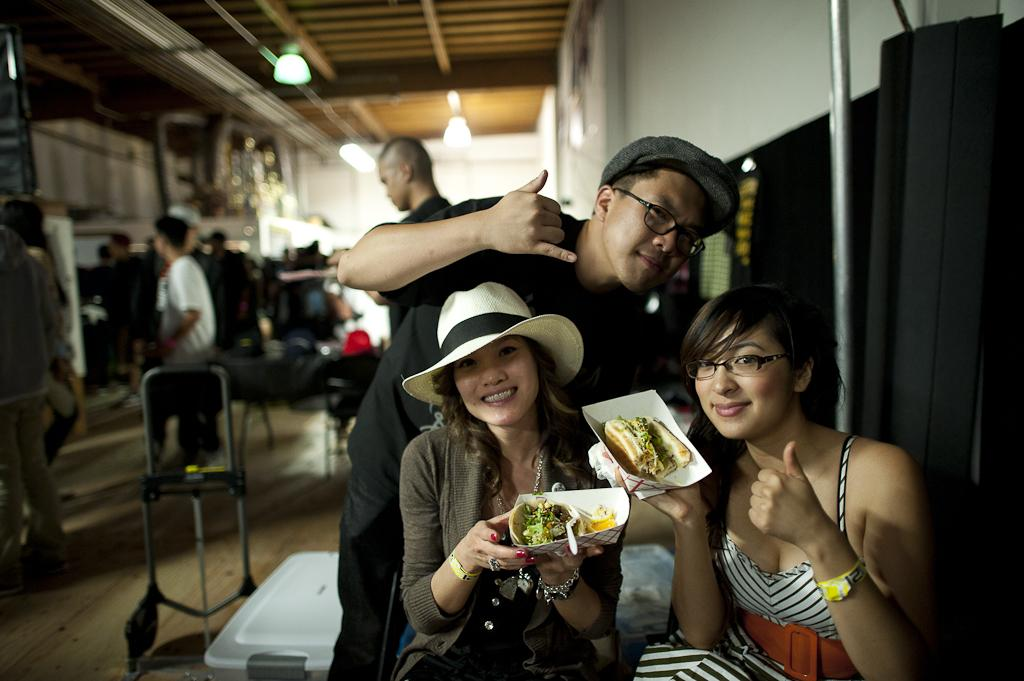What are the persons in the center of the image doing? The persons in the center of the image are holding food in their hands. Can you describe the setting in the background of the image? There are persons, lights, a wall, and a roof visible in the background of the image. How many groups of people can be seen in the image? There are two groups of people in the image: the persons holding food in the center and the persons in the background. What type of chalk is being used to draw on the fold of the tablecloth in the image? There is no chalk or tablecloth present in the image. 